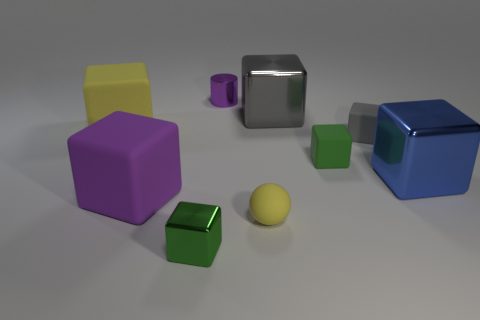Subtract all blue blocks. How many blocks are left? 6 Subtract all tiny green metallic cubes. How many cubes are left? 6 Subtract 4 blocks. How many blocks are left? 3 Subtract all red cubes. Subtract all green cylinders. How many cubes are left? 7 Add 1 small purple metal cylinders. How many objects exist? 10 Subtract all cylinders. How many objects are left? 8 Add 7 tiny gray objects. How many tiny gray objects are left? 8 Add 2 gray metallic cubes. How many gray metallic cubes exist? 3 Subtract 0 gray balls. How many objects are left? 9 Subtract all yellow rubber spheres. Subtract all tiny green balls. How many objects are left? 8 